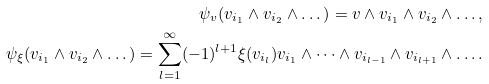<formula> <loc_0><loc_0><loc_500><loc_500>\psi _ { v } ( v _ { i _ { 1 } } \wedge v _ { i _ { 2 } } \wedge \dots ) = v \wedge v _ { i _ { 1 } } \wedge v _ { i _ { 2 } } \wedge \dots , \\ \psi _ { \xi } ( v _ { i _ { 1 } } \wedge v _ { i _ { 2 } } \wedge \dots ) = \sum _ { l = 1 } ^ { \infty } ( - 1 ) ^ { l + 1 } \xi ( v _ { i _ { l } } ) v _ { i _ { 1 } } \wedge \dots \wedge v _ { i _ { l - 1 } } \wedge v _ { i _ { l + 1 } } \wedge \dots .</formula> 